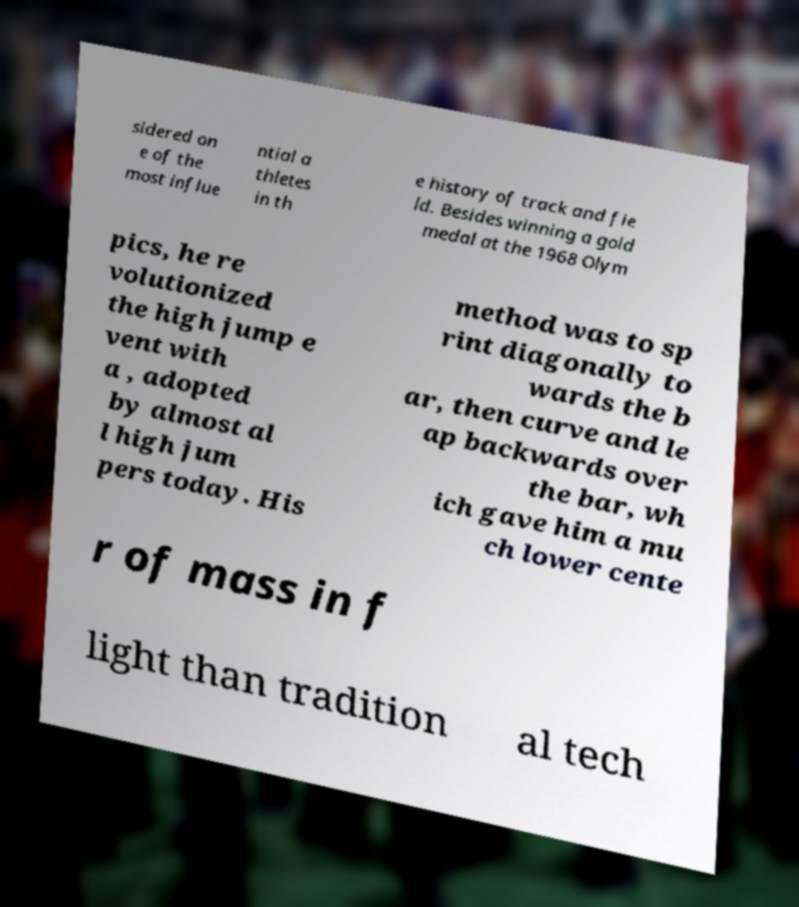There's text embedded in this image that I need extracted. Can you transcribe it verbatim? sidered on e of the most influe ntial a thletes in th e history of track and fie ld. Besides winning a gold medal at the 1968 Olym pics, he re volutionized the high jump e vent with a , adopted by almost al l high jum pers today. His method was to sp rint diagonally to wards the b ar, then curve and le ap backwards over the bar, wh ich gave him a mu ch lower cente r of mass in f light than tradition al tech 